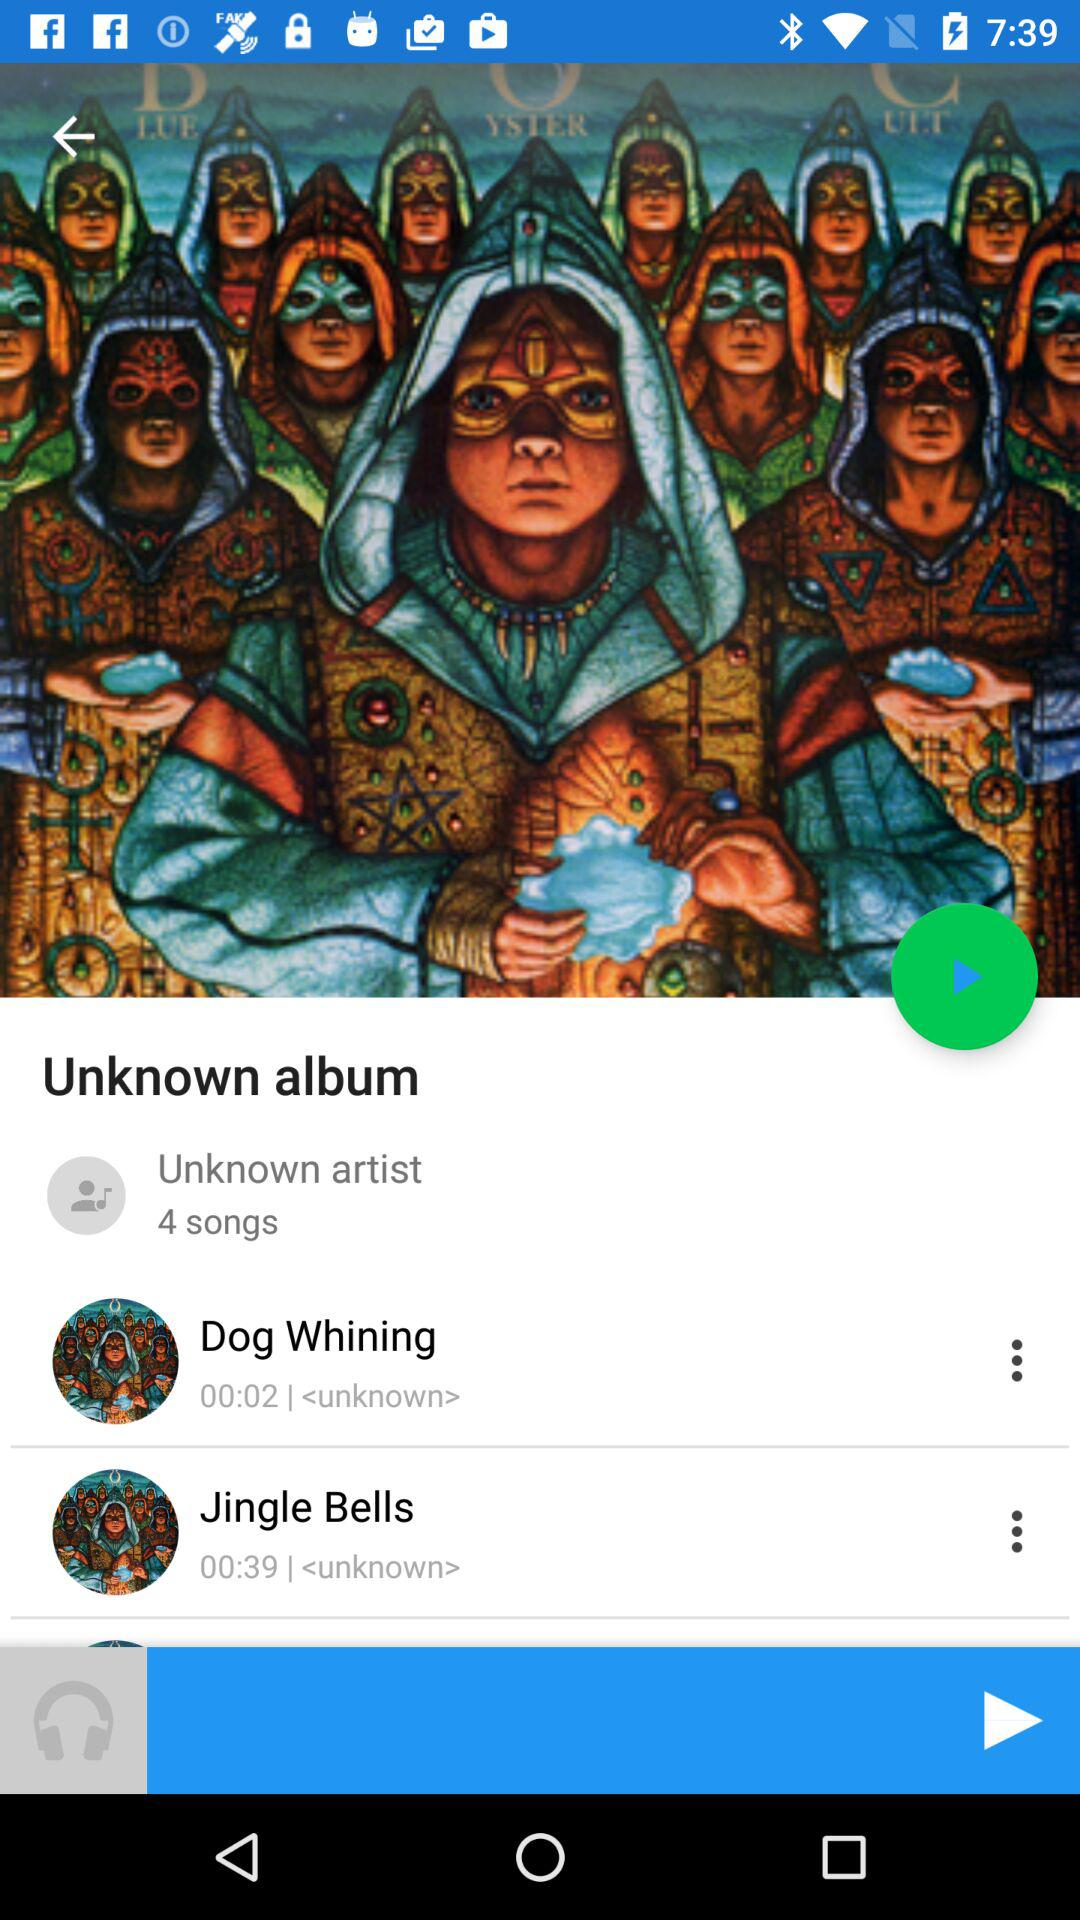How many songs have a duration of less than 30 seconds?
Answer the question using a single word or phrase. 1 